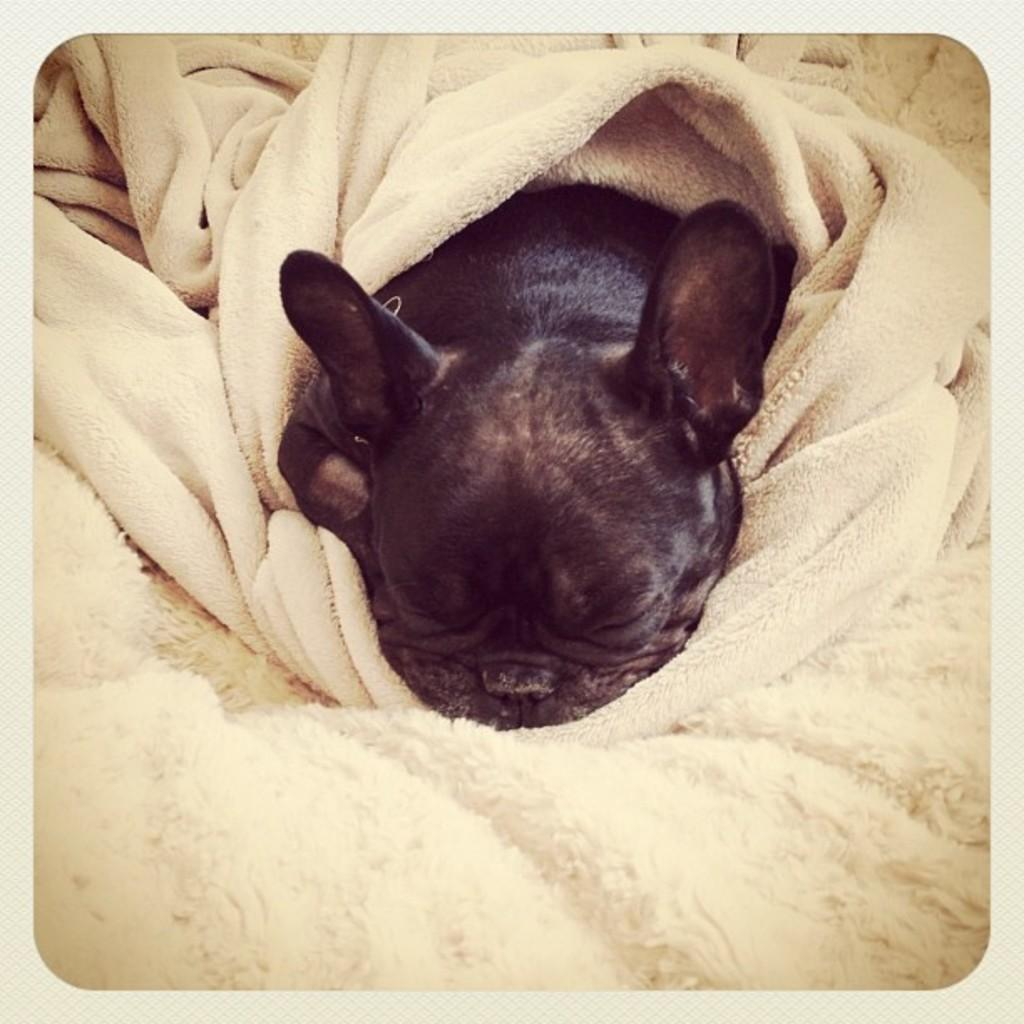What type of animal is present in the image? There is a dog in the image. Is there anything covering the dog? Yes, there is a cloth on the dog. What type of stone is the dog holding in the image? There is no stone present in the image; the dog is covered by a cloth. 